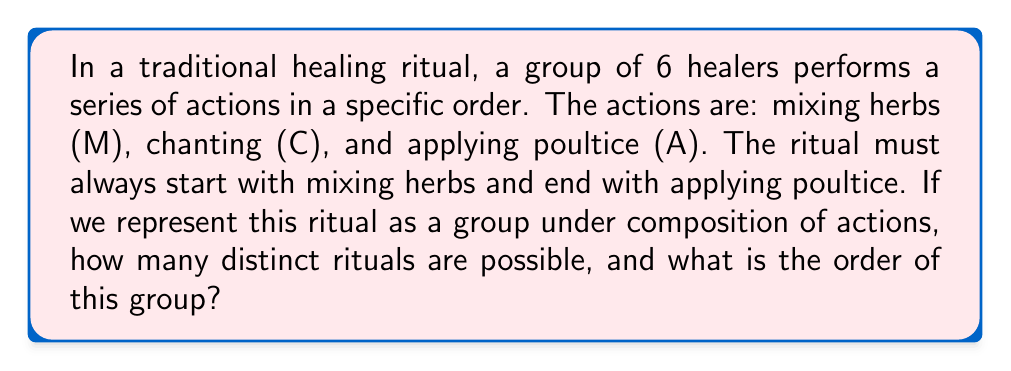What is the answer to this math problem? Let's approach this step-by-step:

1) First, we need to understand the constraints:
   - The ritual always starts with M and ends with A.
   - There are 6 healers, so there will be 6 actions in total.
   - The middle 4 actions can be any combination of M, C, and A.

2) We can represent this as: M _ _ _ _ A, where each blank can be filled with M, C, or A.

3) For each blank, we have 3 choices. Since there are 4 blanks, and each can be filled independently, we can use the multiplication principle.

4) The number of possible rituals is therefore:
   $$ 3 \times 3 \times 3 \times 3 = 3^4 = 81 $$

5) Now, let's consider this as a group under composition of actions. Each distinct ritual can be thought of as an element of the group.

6) The group operation would be performing one ritual followed by another. However, note that this operation isn't well-defined for all pairs of rituals, as the ending A of the first ritual wouldn't match the starting M of the second ritual.

7) To make this a proper group, we could consider the identity element to be MCCCA (doing nothing in the middle), and define the inverse of each ritual as the ritual that would undo its effects.

8) The order of a group is the number of elements in the group. In this case, it's the number of distinct rituals we calculated earlier.

Therefore, this forms a group of order 81.
Answer: There are 81 distinct rituals possible, and the order of this group is 81. 